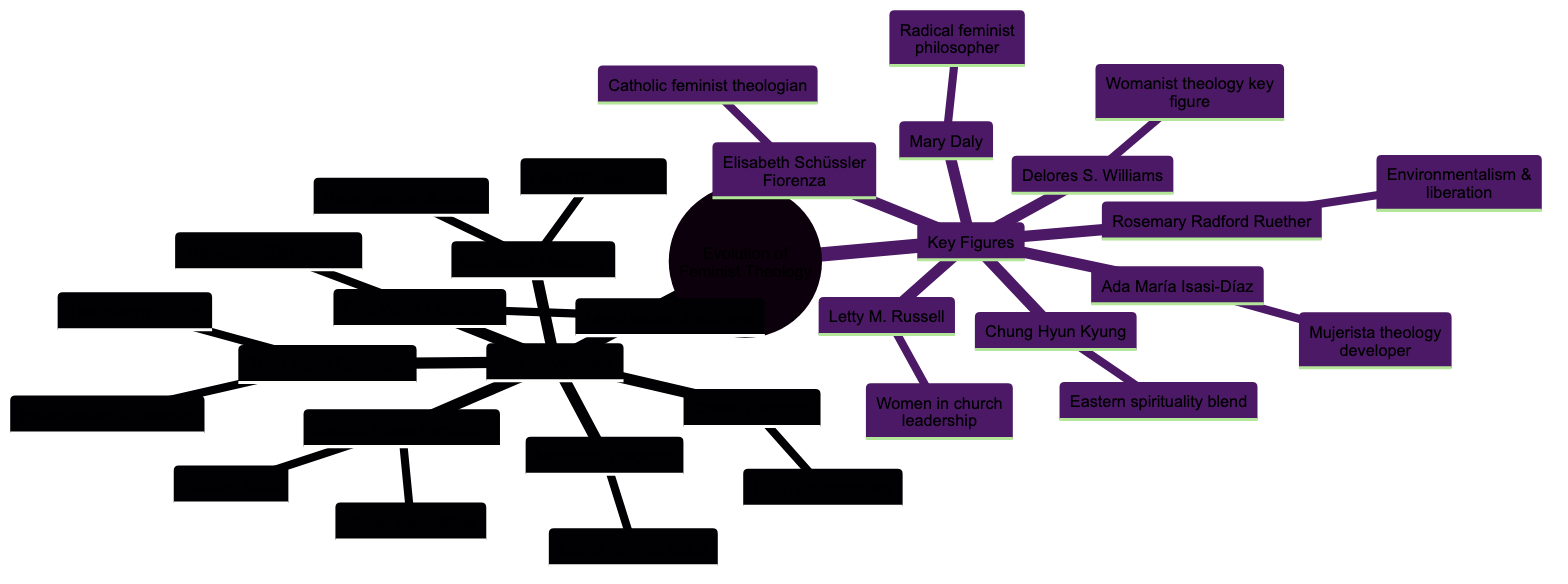What is the time frame for First Wave Feminism? First Wave Feminism is identified with the 19th to early 20th century. This information is found under the "First Wave Feminism" node and states the period clearly.
Answer: 19th to early 20th century How many key movements are listed under Evolution of Feminist Theology? The diagram lists a total of six key movements under the "Key Movements" node. Counting them identifies the total directly.
Answer: 6 Who is known for developing Mujerista theology? The diagram specifies Ada María Isasi-Díaz as the developer of Mujerista theology within the "Key Figures" section. This information directly links her name to that specific theology.
Answer: Ada María Isasi-Díaz What does Womanist Theology focus on? Womanist Theology addresses the intersection of race, gender, and class particularly in the experiences of African American women, as stated within the details node for Womanist Theology.
Answer: Intersection of race, gender, and class Which wave of feminism emphasized individualism and diversity? The diagram indicates that Third Wave Feminism, which is highlighted under the key movements, emphasized individualism and diversity as its main tenets.
Answer: Third Wave Feminism Who is associated with environmentalism and liberation theology? Rosemary Radford Ruether is mentioned in connection with both environmentalism and liberation theology under the "Key Figures" section, making her the person associated with these areas.
Answer: Rosemary Radford Ruether What is the main focus of Queer Theology? The diagram notes that Queer Theology challenges heteronormativity and patriarchal structures in religion while advocating for LGBTQ+ inclusivity, providing a direct description of its main focus.
Answer: LGBTQ+ inclusivity Which key figure criticized patriarchal structures in Christianity? The diagram states that Mary Daly, as noted under "Key Figures," is a radical feminist philosopher who specifically criticized patriarchal structures in Christianity, establishing her as the one who did so.
Answer: Mary Daly How do Womanist and Mujerista Theology differ? Womanist Theology focuses on the experiences of African American women, while Mujerista Theology emphasizes the liberation and spiritual needs of Latina women, showcasing distinct cultural perspectives within feminist theology.
Answer: Cultural perspectives 